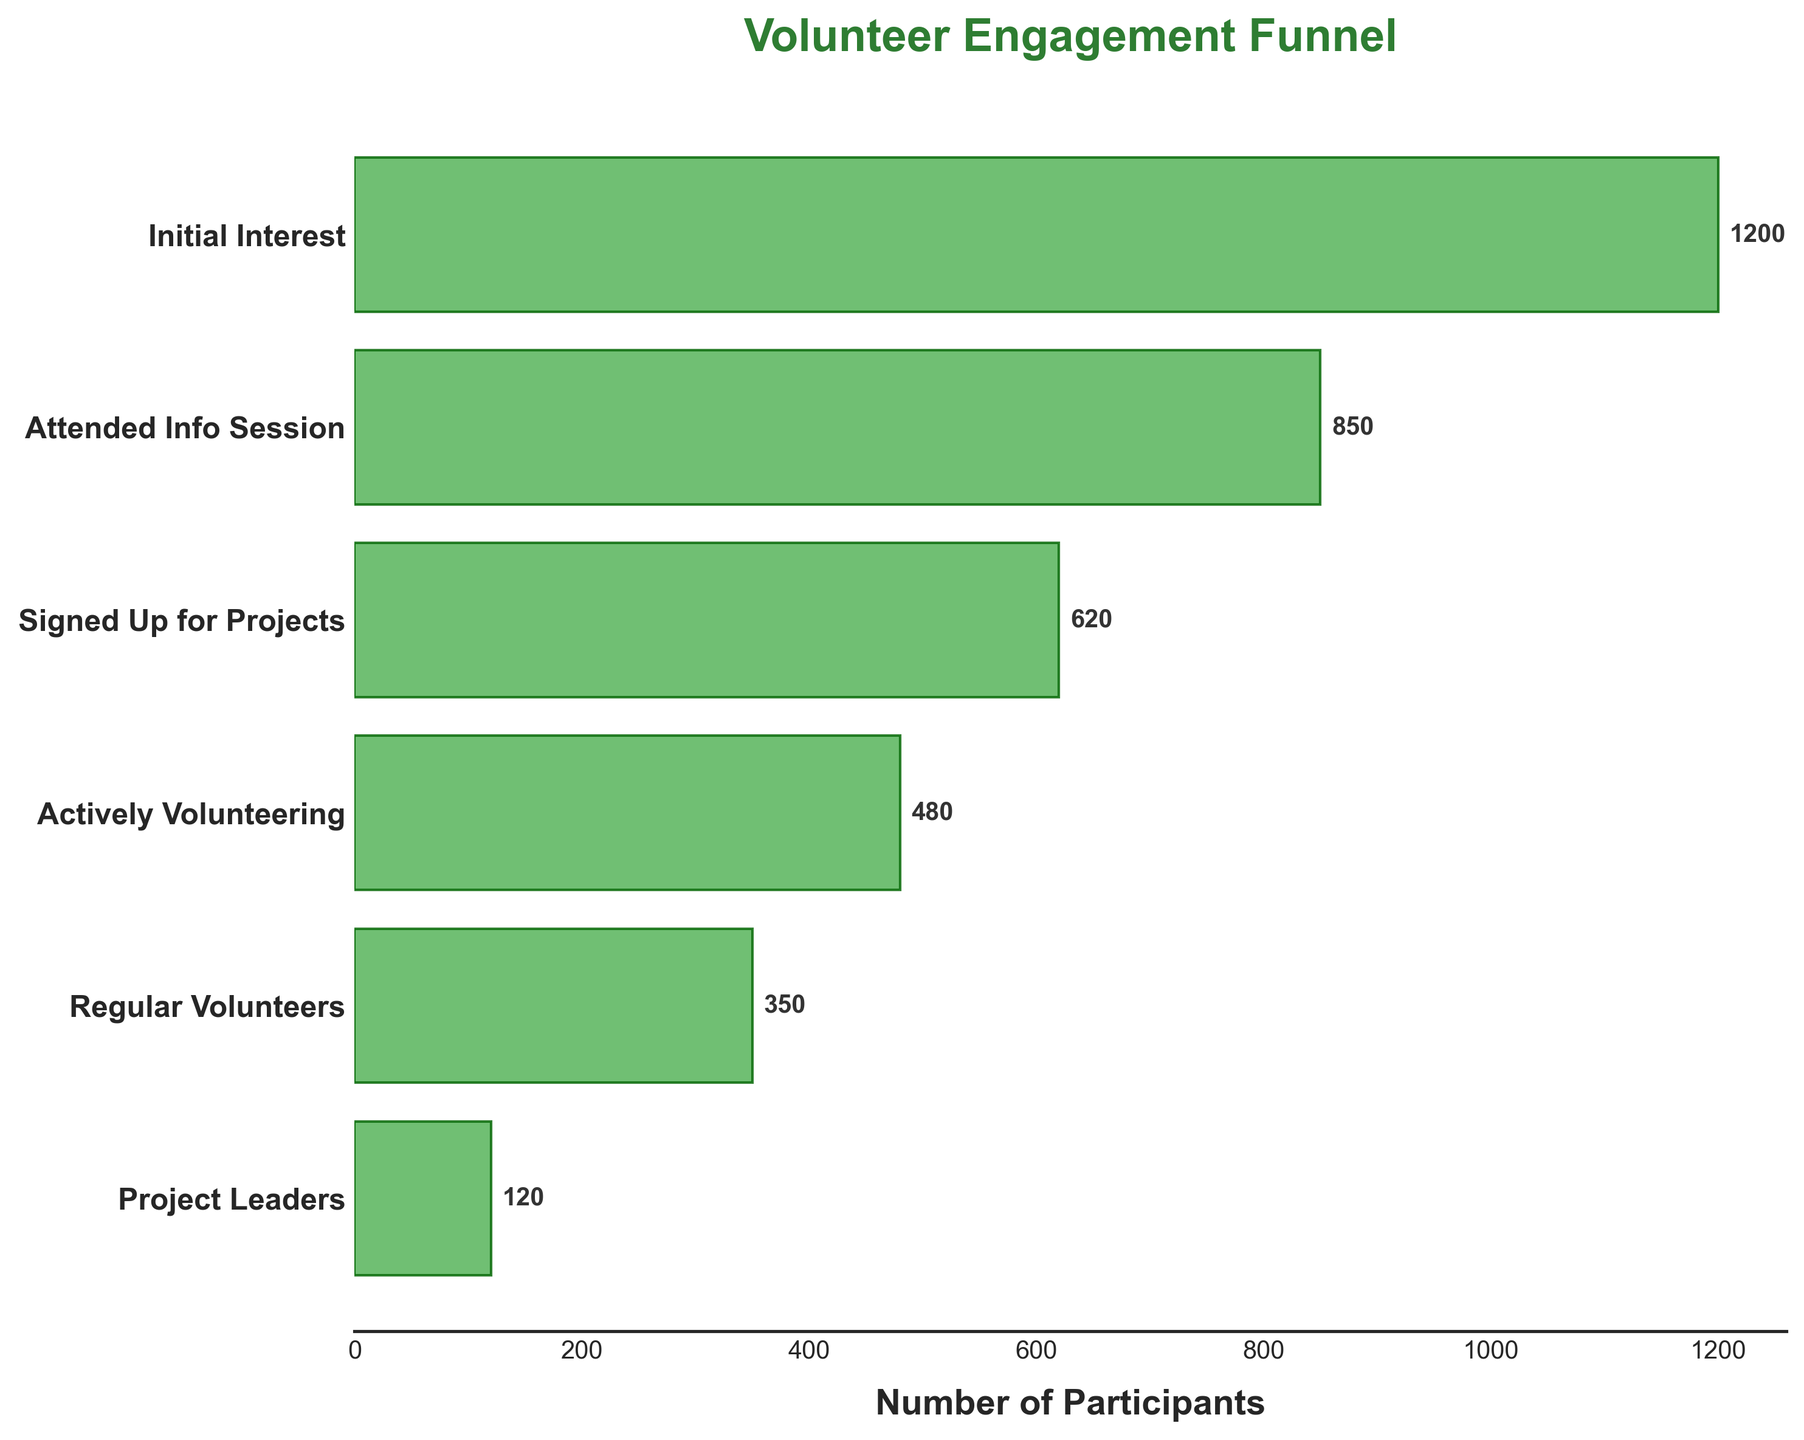What is the title of the funnel chart? The title of the chart is displayed at the top and usually describes the main subject of the data. In this chart, the title clearly states the purpose as "Volunteer Engagement Funnel".
Answer: Volunteer Engagement Funnel How many stages are shown in the funnel chart? The chart has a y-axis listing stages from top to bottom. By counting these stages, we can determine the number of stages represented in the chart, which are six in total.
Answer: Six What is the number of participants in the "Regular Volunteers" stage? To find the number of participants, look at the bar corresponding to the "Regular Volunteers" stage on the y-axis, and read the value from the text beside the bar, which shows the exact number.
Answer: 350 How many more participants showed initial interest compared to those who became project leaders? To find the difference, subtract the number of participants who became project leaders from those who showed initial interest. This is 1200 (Initial Interest) - 120 (Project Leaders).
Answer: 1080 How many participants dropped off between the "Attended Info Session" and "Signed Up for Projects" stages? Subtract the number of participants at the "Signed Up for Projects" stage from the "Attended Info Session" stage. This is 850 (Attended Info Session) - 620 (Signed Up for Projects).
Answer: 230 Which stage has the lowest number of participants? By looking at the length of each bar, the shortest bar corresponds to the stage with the lowest number of participants, which is "Project Leaders".
Answer: Project Leaders List the stages where the number of participants is more than 500. To determine this, examine each bar and note the stages where the number of participants exceeds 500. The stages satisfying this condition are "Initial Interest", "Attended Info Session", and "Signed Up for Projects".
Answer: Initial Interest, Attended Info Session, Signed Up for Projects What percentage of the initial participants are actively volunteering? Divide the number of participants who are actively volunteering by the number who showed initial interest and multiply by 100. This is (480 / 1200) * 100 = 40%.
Answer: 40% Which stages have fewer than 500 participants? Look at the lengths of the bars and the data at the end of each bar. The stages where the participant number is below 500 are "Actively Volunteering", "Regular Volunteers", and "Project Leaders".
Answer: Actively Volunteering, Regular Volunteers, Project Leaders What is the combined number of participants in the "Signed Up for Projects" and "Actively Volunteering" stages? Add the number of participants in both stages. This is 620 ("Signed Up for Projects") + 480 ("Actively Volunteering").
Answer: 1100 Calculate the average number of participants across all stages. Add the number of participants at each stage and divide by the total number of stages. This is (1200 + 850 + 620 + 480 + 350 + 120) / 6 = 6200 / 6 = 1033.33.
Answer: 1033.33 